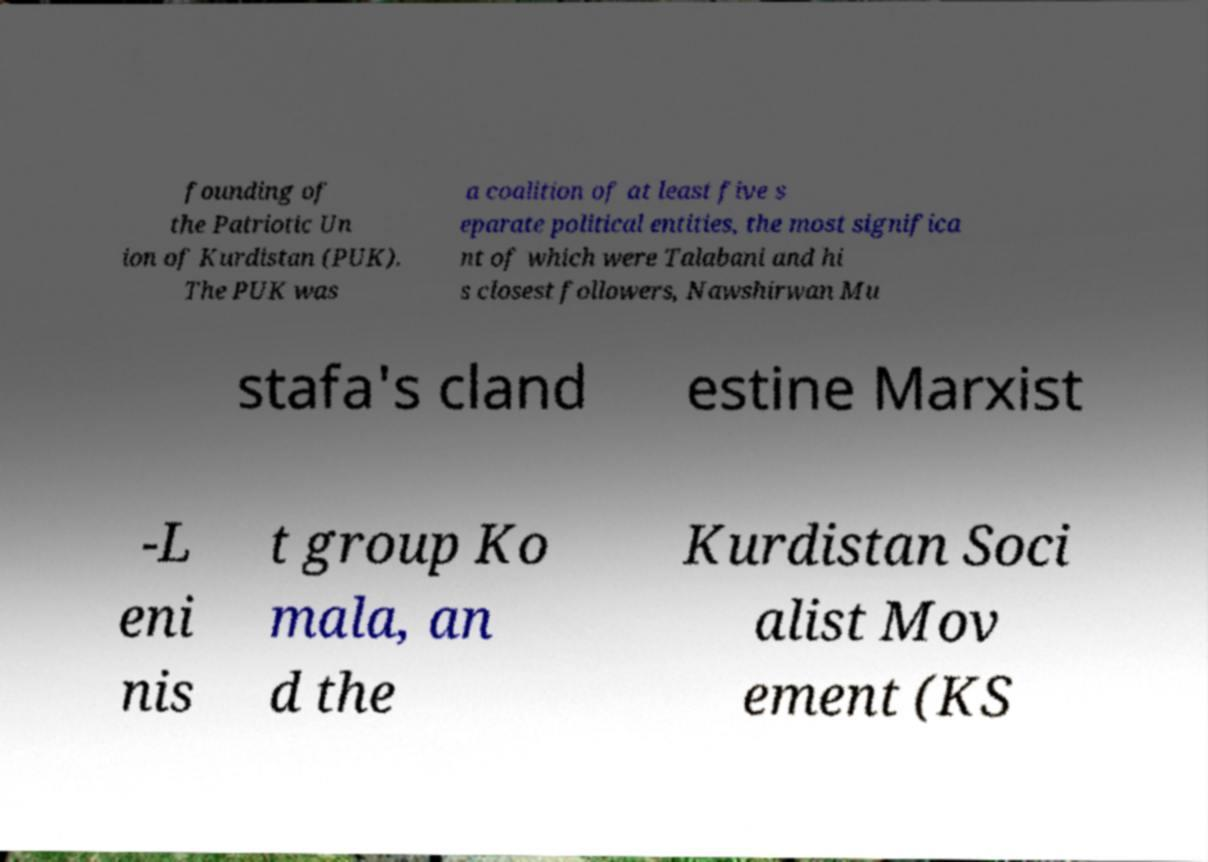For documentation purposes, I need the text within this image transcribed. Could you provide that? founding of the Patriotic Un ion of Kurdistan (PUK). The PUK was a coalition of at least five s eparate political entities, the most significa nt of which were Talabani and hi s closest followers, Nawshirwan Mu stafa's cland estine Marxist -L eni nis t group Ko mala, an d the Kurdistan Soci alist Mov ement (KS 